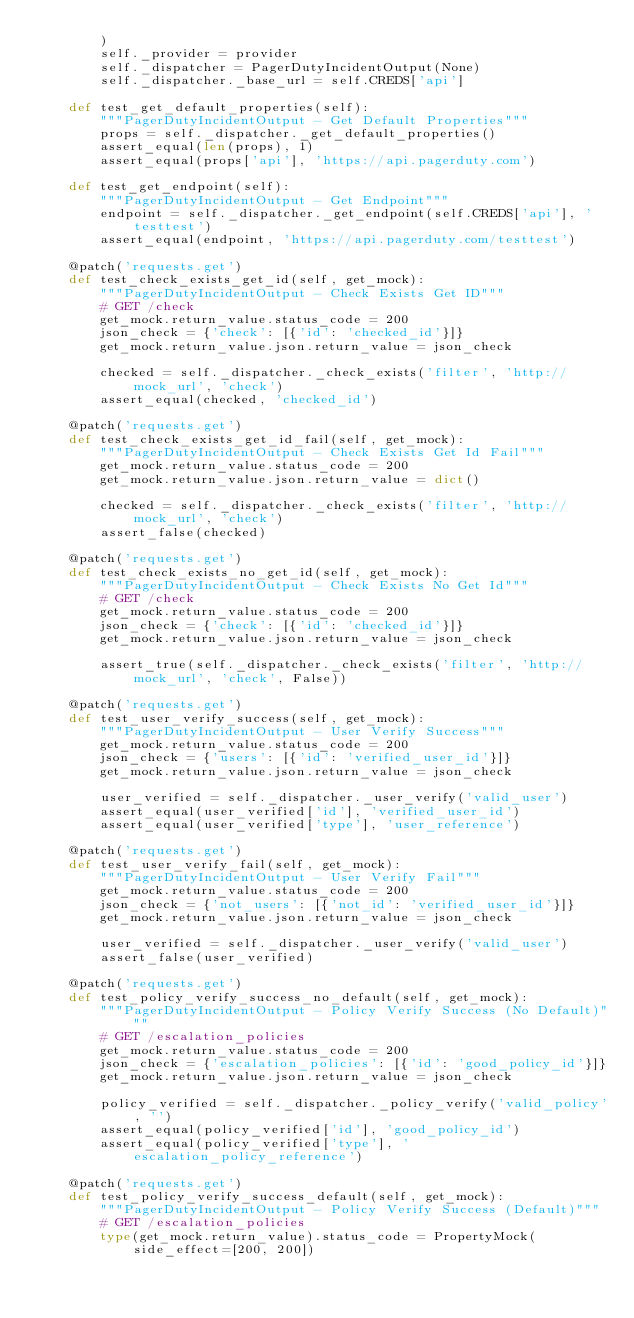<code> <loc_0><loc_0><loc_500><loc_500><_Python_>        )
        self._provider = provider
        self._dispatcher = PagerDutyIncidentOutput(None)
        self._dispatcher._base_url = self.CREDS['api']

    def test_get_default_properties(self):
        """PagerDutyIncidentOutput - Get Default Properties"""
        props = self._dispatcher._get_default_properties()
        assert_equal(len(props), 1)
        assert_equal(props['api'], 'https://api.pagerduty.com')

    def test_get_endpoint(self):
        """PagerDutyIncidentOutput - Get Endpoint"""
        endpoint = self._dispatcher._get_endpoint(self.CREDS['api'], 'testtest')
        assert_equal(endpoint, 'https://api.pagerduty.com/testtest')

    @patch('requests.get')
    def test_check_exists_get_id(self, get_mock):
        """PagerDutyIncidentOutput - Check Exists Get ID"""
        # GET /check
        get_mock.return_value.status_code = 200
        json_check = {'check': [{'id': 'checked_id'}]}
        get_mock.return_value.json.return_value = json_check

        checked = self._dispatcher._check_exists('filter', 'http://mock_url', 'check')
        assert_equal(checked, 'checked_id')

    @patch('requests.get')
    def test_check_exists_get_id_fail(self, get_mock):
        """PagerDutyIncidentOutput - Check Exists Get Id Fail"""
        get_mock.return_value.status_code = 200
        get_mock.return_value.json.return_value = dict()

        checked = self._dispatcher._check_exists('filter', 'http://mock_url', 'check')
        assert_false(checked)

    @patch('requests.get')
    def test_check_exists_no_get_id(self, get_mock):
        """PagerDutyIncidentOutput - Check Exists No Get Id"""
        # GET /check
        get_mock.return_value.status_code = 200
        json_check = {'check': [{'id': 'checked_id'}]}
        get_mock.return_value.json.return_value = json_check

        assert_true(self._dispatcher._check_exists('filter', 'http://mock_url', 'check', False))

    @patch('requests.get')
    def test_user_verify_success(self, get_mock):
        """PagerDutyIncidentOutput - User Verify Success"""
        get_mock.return_value.status_code = 200
        json_check = {'users': [{'id': 'verified_user_id'}]}
        get_mock.return_value.json.return_value = json_check

        user_verified = self._dispatcher._user_verify('valid_user')
        assert_equal(user_verified['id'], 'verified_user_id')
        assert_equal(user_verified['type'], 'user_reference')

    @patch('requests.get')
    def test_user_verify_fail(self, get_mock):
        """PagerDutyIncidentOutput - User Verify Fail"""
        get_mock.return_value.status_code = 200
        json_check = {'not_users': [{'not_id': 'verified_user_id'}]}
        get_mock.return_value.json.return_value = json_check

        user_verified = self._dispatcher._user_verify('valid_user')
        assert_false(user_verified)

    @patch('requests.get')
    def test_policy_verify_success_no_default(self, get_mock):
        """PagerDutyIncidentOutput - Policy Verify Success (No Default)"""
        # GET /escalation_policies
        get_mock.return_value.status_code = 200
        json_check = {'escalation_policies': [{'id': 'good_policy_id'}]}
        get_mock.return_value.json.return_value = json_check

        policy_verified = self._dispatcher._policy_verify('valid_policy', '')
        assert_equal(policy_verified['id'], 'good_policy_id')
        assert_equal(policy_verified['type'], 'escalation_policy_reference')

    @patch('requests.get')
    def test_policy_verify_success_default(self, get_mock):
        """PagerDutyIncidentOutput - Policy Verify Success (Default)"""
        # GET /escalation_policies
        type(get_mock.return_value).status_code = PropertyMock(side_effect=[200, 200])</code> 